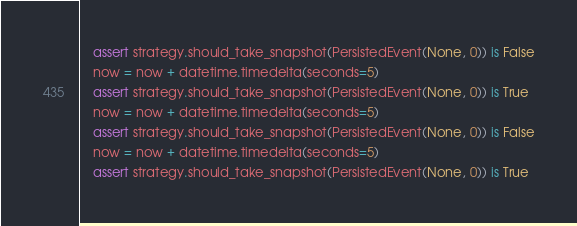Convert code to text. <code><loc_0><loc_0><loc_500><loc_500><_Python_>    assert strategy.should_take_snapshot(PersistedEvent(None, 0)) is False
    now = now + datetime.timedelta(seconds=5)
    assert strategy.should_take_snapshot(PersistedEvent(None, 0)) is True
    now = now + datetime.timedelta(seconds=5)
    assert strategy.should_take_snapshot(PersistedEvent(None, 0)) is False
    now = now + datetime.timedelta(seconds=5)
    assert strategy.should_take_snapshot(PersistedEvent(None, 0)) is True</code> 